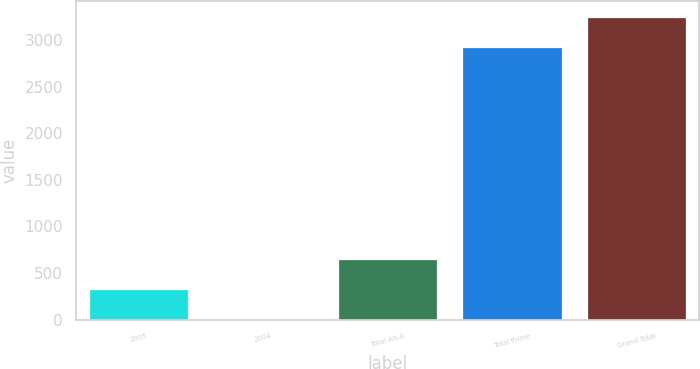<chart> <loc_0><loc_0><loc_500><loc_500><bar_chart><fcel>2005<fcel>2004<fcel>Total Alt-A<fcel>Total Prime<fcel>Grand Total<nl><fcel>330.9<fcel>10<fcel>651.8<fcel>2929<fcel>3249.9<nl></chart> 